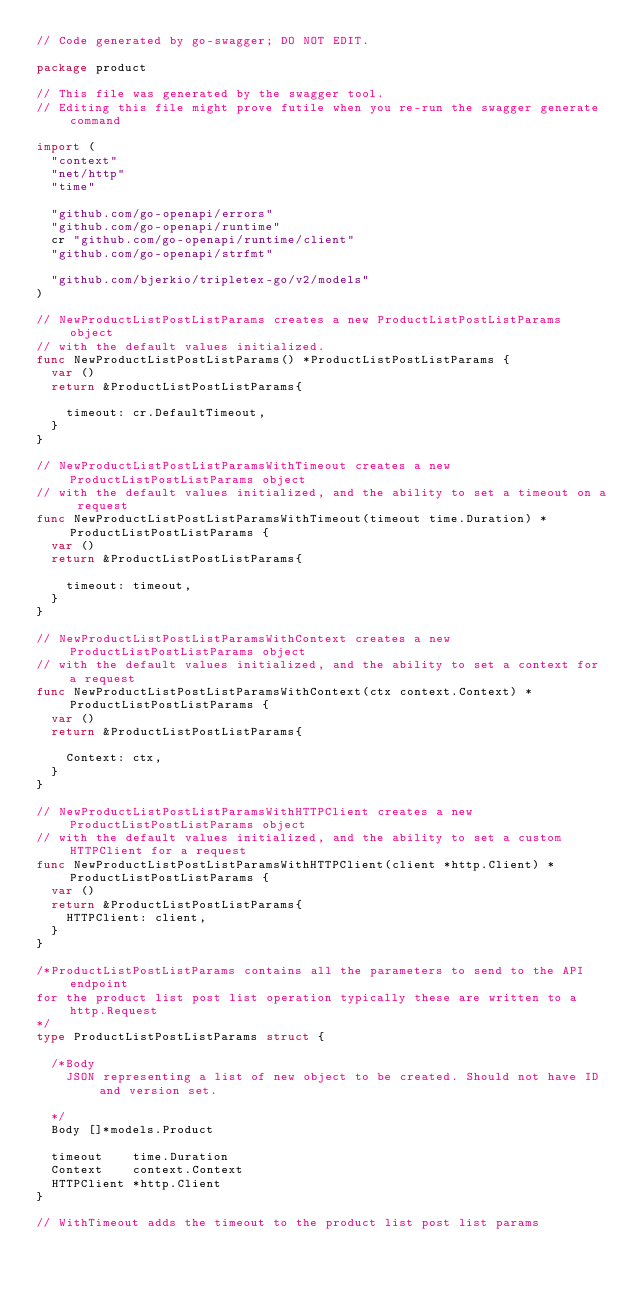Convert code to text. <code><loc_0><loc_0><loc_500><loc_500><_Go_>// Code generated by go-swagger; DO NOT EDIT.

package product

// This file was generated by the swagger tool.
// Editing this file might prove futile when you re-run the swagger generate command

import (
	"context"
	"net/http"
	"time"

	"github.com/go-openapi/errors"
	"github.com/go-openapi/runtime"
	cr "github.com/go-openapi/runtime/client"
	"github.com/go-openapi/strfmt"

	"github.com/bjerkio/tripletex-go/v2/models"
)

// NewProductListPostListParams creates a new ProductListPostListParams object
// with the default values initialized.
func NewProductListPostListParams() *ProductListPostListParams {
	var ()
	return &ProductListPostListParams{

		timeout: cr.DefaultTimeout,
	}
}

// NewProductListPostListParamsWithTimeout creates a new ProductListPostListParams object
// with the default values initialized, and the ability to set a timeout on a request
func NewProductListPostListParamsWithTimeout(timeout time.Duration) *ProductListPostListParams {
	var ()
	return &ProductListPostListParams{

		timeout: timeout,
	}
}

// NewProductListPostListParamsWithContext creates a new ProductListPostListParams object
// with the default values initialized, and the ability to set a context for a request
func NewProductListPostListParamsWithContext(ctx context.Context) *ProductListPostListParams {
	var ()
	return &ProductListPostListParams{

		Context: ctx,
	}
}

// NewProductListPostListParamsWithHTTPClient creates a new ProductListPostListParams object
// with the default values initialized, and the ability to set a custom HTTPClient for a request
func NewProductListPostListParamsWithHTTPClient(client *http.Client) *ProductListPostListParams {
	var ()
	return &ProductListPostListParams{
		HTTPClient: client,
	}
}

/*ProductListPostListParams contains all the parameters to send to the API endpoint
for the product list post list operation typically these are written to a http.Request
*/
type ProductListPostListParams struct {

	/*Body
	  JSON representing a list of new object to be created. Should not have ID and version set.

	*/
	Body []*models.Product

	timeout    time.Duration
	Context    context.Context
	HTTPClient *http.Client
}

// WithTimeout adds the timeout to the product list post list params</code> 